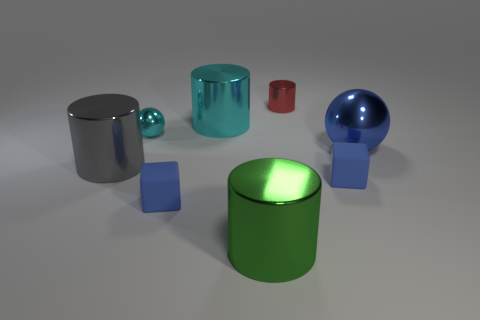What number of small green blocks have the same material as the small cyan object?
Keep it short and to the point. 0. How many shiny cylinders are there?
Make the answer very short. 4. Does the rubber object to the left of the green metallic cylinder have the same color as the tiny matte thing that is right of the big cyan cylinder?
Ensure brevity in your answer.  Yes. What number of large metal objects are behind the tiny cyan sphere?
Give a very brief answer. 1. What is the material of the large cylinder that is the same color as the tiny metallic sphere?
Offer a very short reply. Metal. Is there a small blue object of the same shape as the big blue metal thing?
Your response must be concise. No. Does the blue object behind the big gray object have the same material as the tiny cube to the left of the tiny red thing?
Provide a succinct answer. No. What size is the ball behind the big metallic ball right of the tiny matte block that is on the left side of the red metallic cylinder?
Ensure brevity in your answer.  Small. There is a gray cylinder that is the same size as the cyan metal cylinder; what is it made of?
Keep it short and to the point. Metal. Are there any blue shiny things of the same size as the red shiny thing?
Offer a terse response. No. 